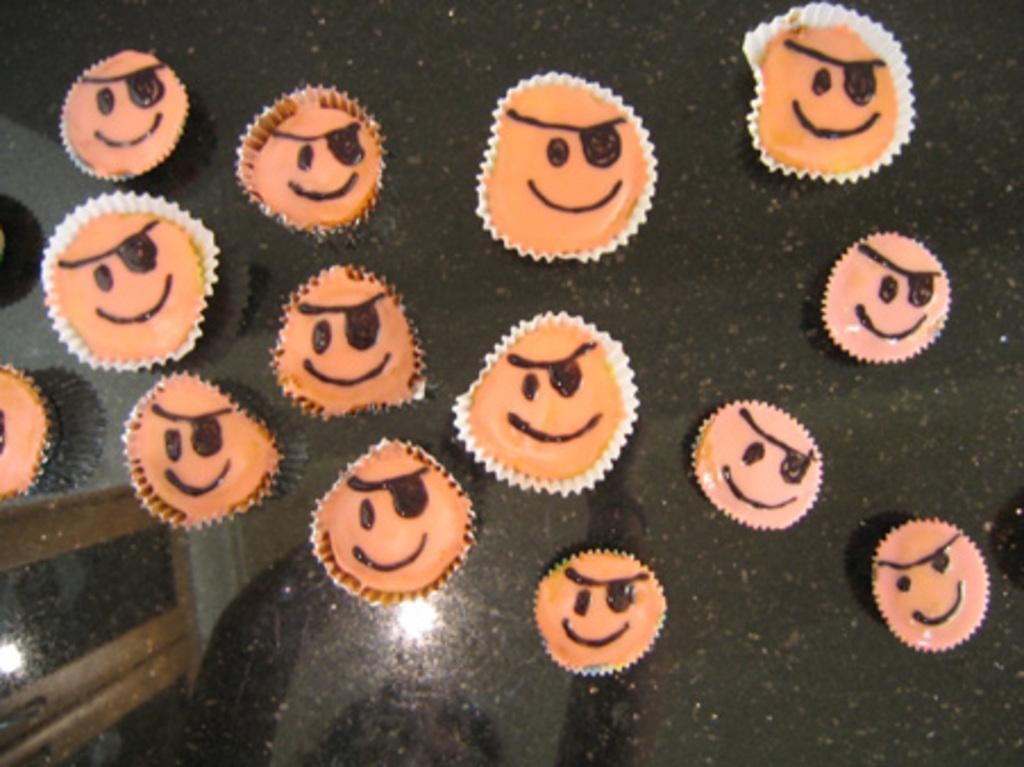What type of food is visible in the image? There are cupcakes in the image. Where are the cupcakes located? The cupcakes are placed on a surface. Is there a boy holding a slave in the image? There is no boy or slave present in the image; it only features cupcakes placed on a surface. 